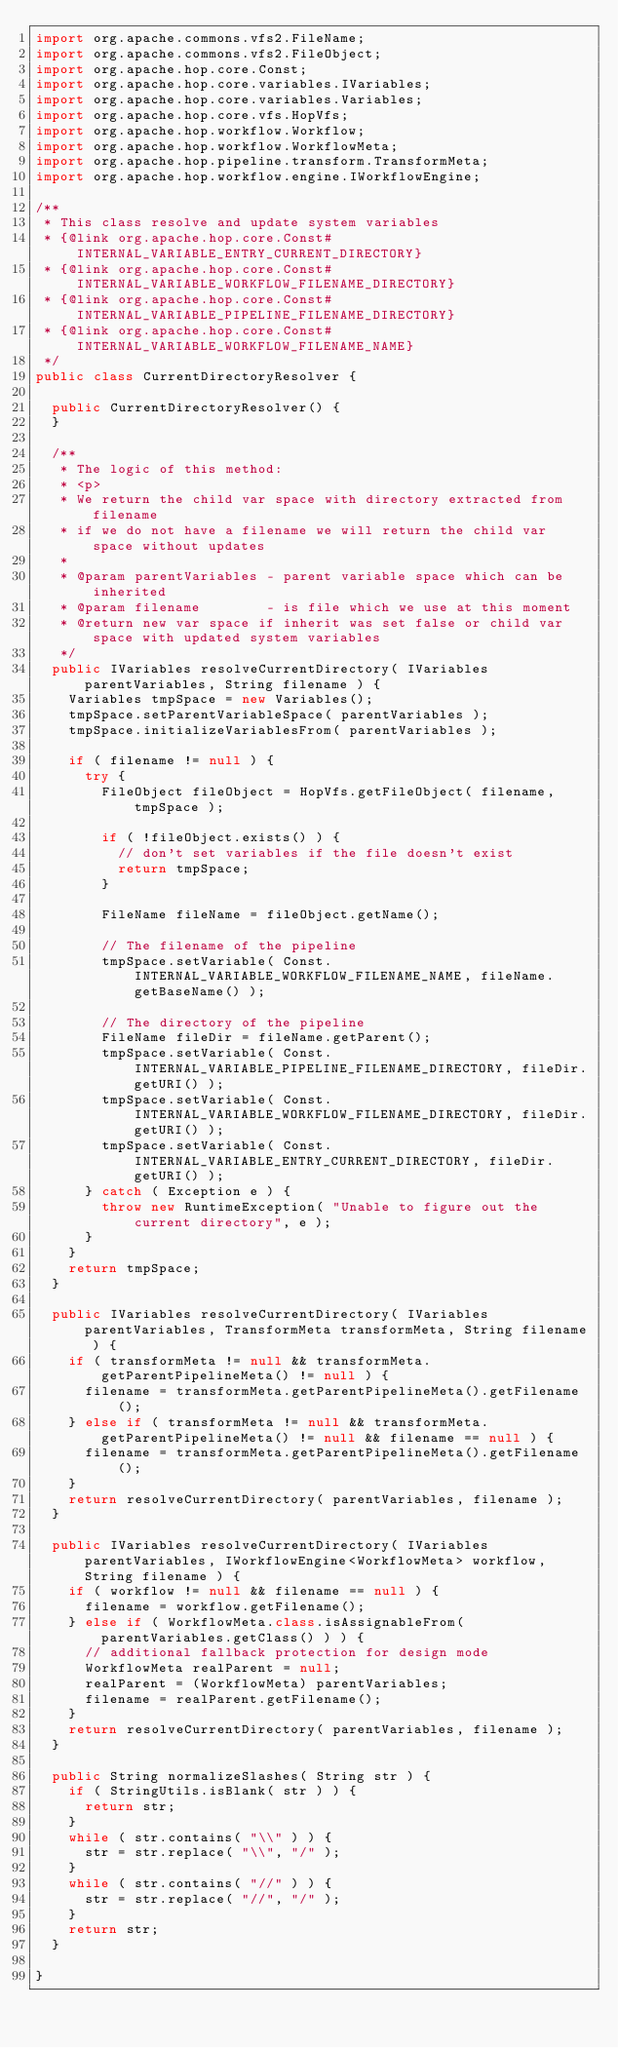Convert code to text. <code><loc_0><loc_0><loc_500><loc_500><_Java_>import org.apache.commons.vfs2.FileName;
import org.apache.commons.vfs2.FileObject;
import org.apache.hop.core.Const;
import org.apache.hop.core.variables.IVariables;
import org.apache.hop.core.variables.Variables;
import org.apache.hop.core.vfs.HopVfs;
import org.apache.hop.workflow.Workflow;
import org.apache.hop.workflow.WorkflowMeta;
import org.apache.hop.pipeline.transform.TransformMeta;
import org.apache.hop.workflow.engine.IWorkflowEngine;

/**
 * This class resolve and update system variables
 * {@link org.apache.hop.core.Const#INTERNAL_VARIABLE_ENTRY_CURRENT_DIRECTORY}
 * {@link org.apache.hop.core.Const#INTERNAL_VARIABLE_WORKFLOW_FILENAME_DIRECTORY}
 * {@link org.apache.hop.core.Const#INTERNAL_VARIABLE_PIPELINE_FILENAME_DIRECTORY}
 * {@link org.apache.hop.core.Const#INTERNAL_VARIABLE_WORKFLOW_FILENAME_NAME}
 */
public class CurrentDirectoryResolver {

  public CurrentDirectoryResolver() {
  }

  /**
   * The logic of this method:
   * <p>
   * We return the child var space with directory extracted from filename
   * if we do not have a filename we will return the child var space without updates
   *
   * @param parentVariables - parent variable space which can be inherited
   * @param filename        - is file which we use at this moment
   * @return new var space if inherit was set false or child var space with updated system variables
   */
  public IVariables resolveCurrentDirectory( IVariables parentVariables, String filename ) {
    Variables tmpSpace = new Variables();
    tmpSpace.setParentVariableSpace( parentVariables );
    tmpSpace.initializeVariablesFrom( parentVariables );

    if ( filename != null ) {
      try {
        FileObject fileObject = HopVfs.getFileObject( filename, tmpSpace );

        if ( !fileObject.exists() ) {
          // don't set variables if the file doesn't exist
          return tmpSpace;
        }

        FileName fileName = fileObject.getName();

        // The filename of the pipeline
        tmpSpace.setVariable( Const.INTERNAL_VARIABLE_WORKFLOW_FILENAME_NAME, fileName.getBaseName() );

        // The directory of the pipeline
        FileName fileDir = fileName.getParent();
        tmpSpace.setVariable( Const.INTERNAL_VARIABLE_PIPELINE_FILENAME_DIRECTORY, fileDir.getURI() );
        tmpSpace.setVariable( Const.INTERNAL_VARIABLE_WORKFLOW_FILENAME_DIRECTORY, fileDir.getURI() );
        tmpSpace.setVariable( Const.INTERNAL_VARIABLE_ENTRY_CURRENT_DIRECTORY, fileDir.getURI() );
      } catch ( Exception e ) {
        throw new RuntimeException( "Unable to figure out the current directory", e );
      }
    }
    return tmpSpace;
  }

  public IVariables resolveCurrentDirectory( IVariables parentVariables, TransformMeta transformMeta, String filename ) {
    if ( transformMeta != null && transformMeta.getParentPipelineMeta() != null ) {
      filename = transformMeta.getParentPipelineMeta().getFilename();
    } else if ( transformMeta != null && transformMeta.getParentPipelineMeta() != null && filename == null ) {
      filename = transformMeta.getParentPipelineMeta().getFilename();
    }
    return resolveCurrentDirectory( parentVariables, filename );
  }

  public IVariables resolveCurrentDirectory( IVariables parentVariables, IWorkflowEngine<WorkflowMeta> workflow, String filename ) {
    if ( workflow != null && filename == null ) {
      filename = workflow.getFilename();
    } else if ( WorkflowMeta.class.isAssignableFrom( parentVariables.getClass() ) ) {
      // additional fallback protection for design mode
      WorkflowMeta realParent = null;
      realParent = (WorkflowMeta) parentVariables;
      filename = realParent.getFilename();
    }
    return resolveCurrentDirectory( parentVariables, filename );
  }

  public String normalizeSlashes( String str ) {
    if ( StringUtils.isBlank( str ) ) {
      return str;
    }
    while ( str.contains( "\\" ) ) {
      str = str.replace( "\\", "/" );
    }
    while ( str.contains( "//" ) ) {
      str = str.replace( "//", "/" );
    }
    return str;
  }

}
</code> 